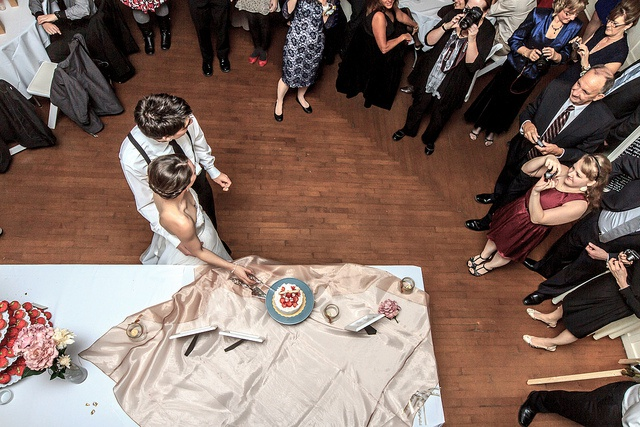Describe the objects in this image and their specific colors. I can see dining table in brown, lightgray, tan, and darkgray tones, people in brown, black, and maroon tones, people in brown, black, tan, and gray tones, people in brown, maroon, black, and tan tones, and people in brown, lightgray, black, darkgray, and gray tones in this image. 